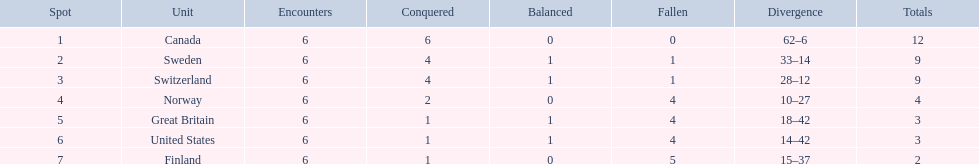What team placed next after sweden? Switzerland. 